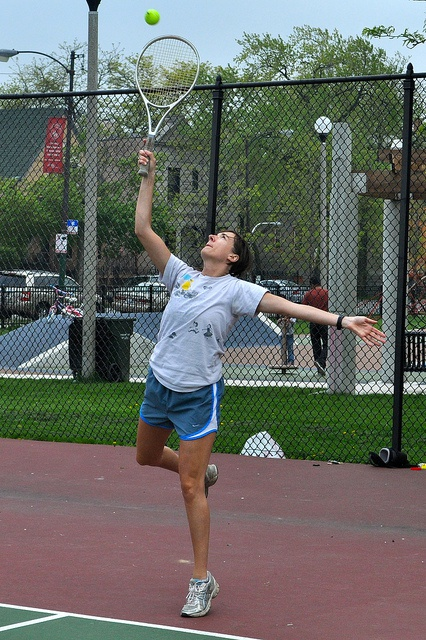Describe the objects in this image and their specific colors. I can see people in lightblue, gray, and darkgray tones, tennis racket in lightblue, darkgray, and gray tones, car in lightblue, black, gray, purple, and darkgray tones, car in lightblue, black, gray, darkgray, and lightgray tones, and people in lightblue, black, maroon, gray, and darkgray tones in this image. 